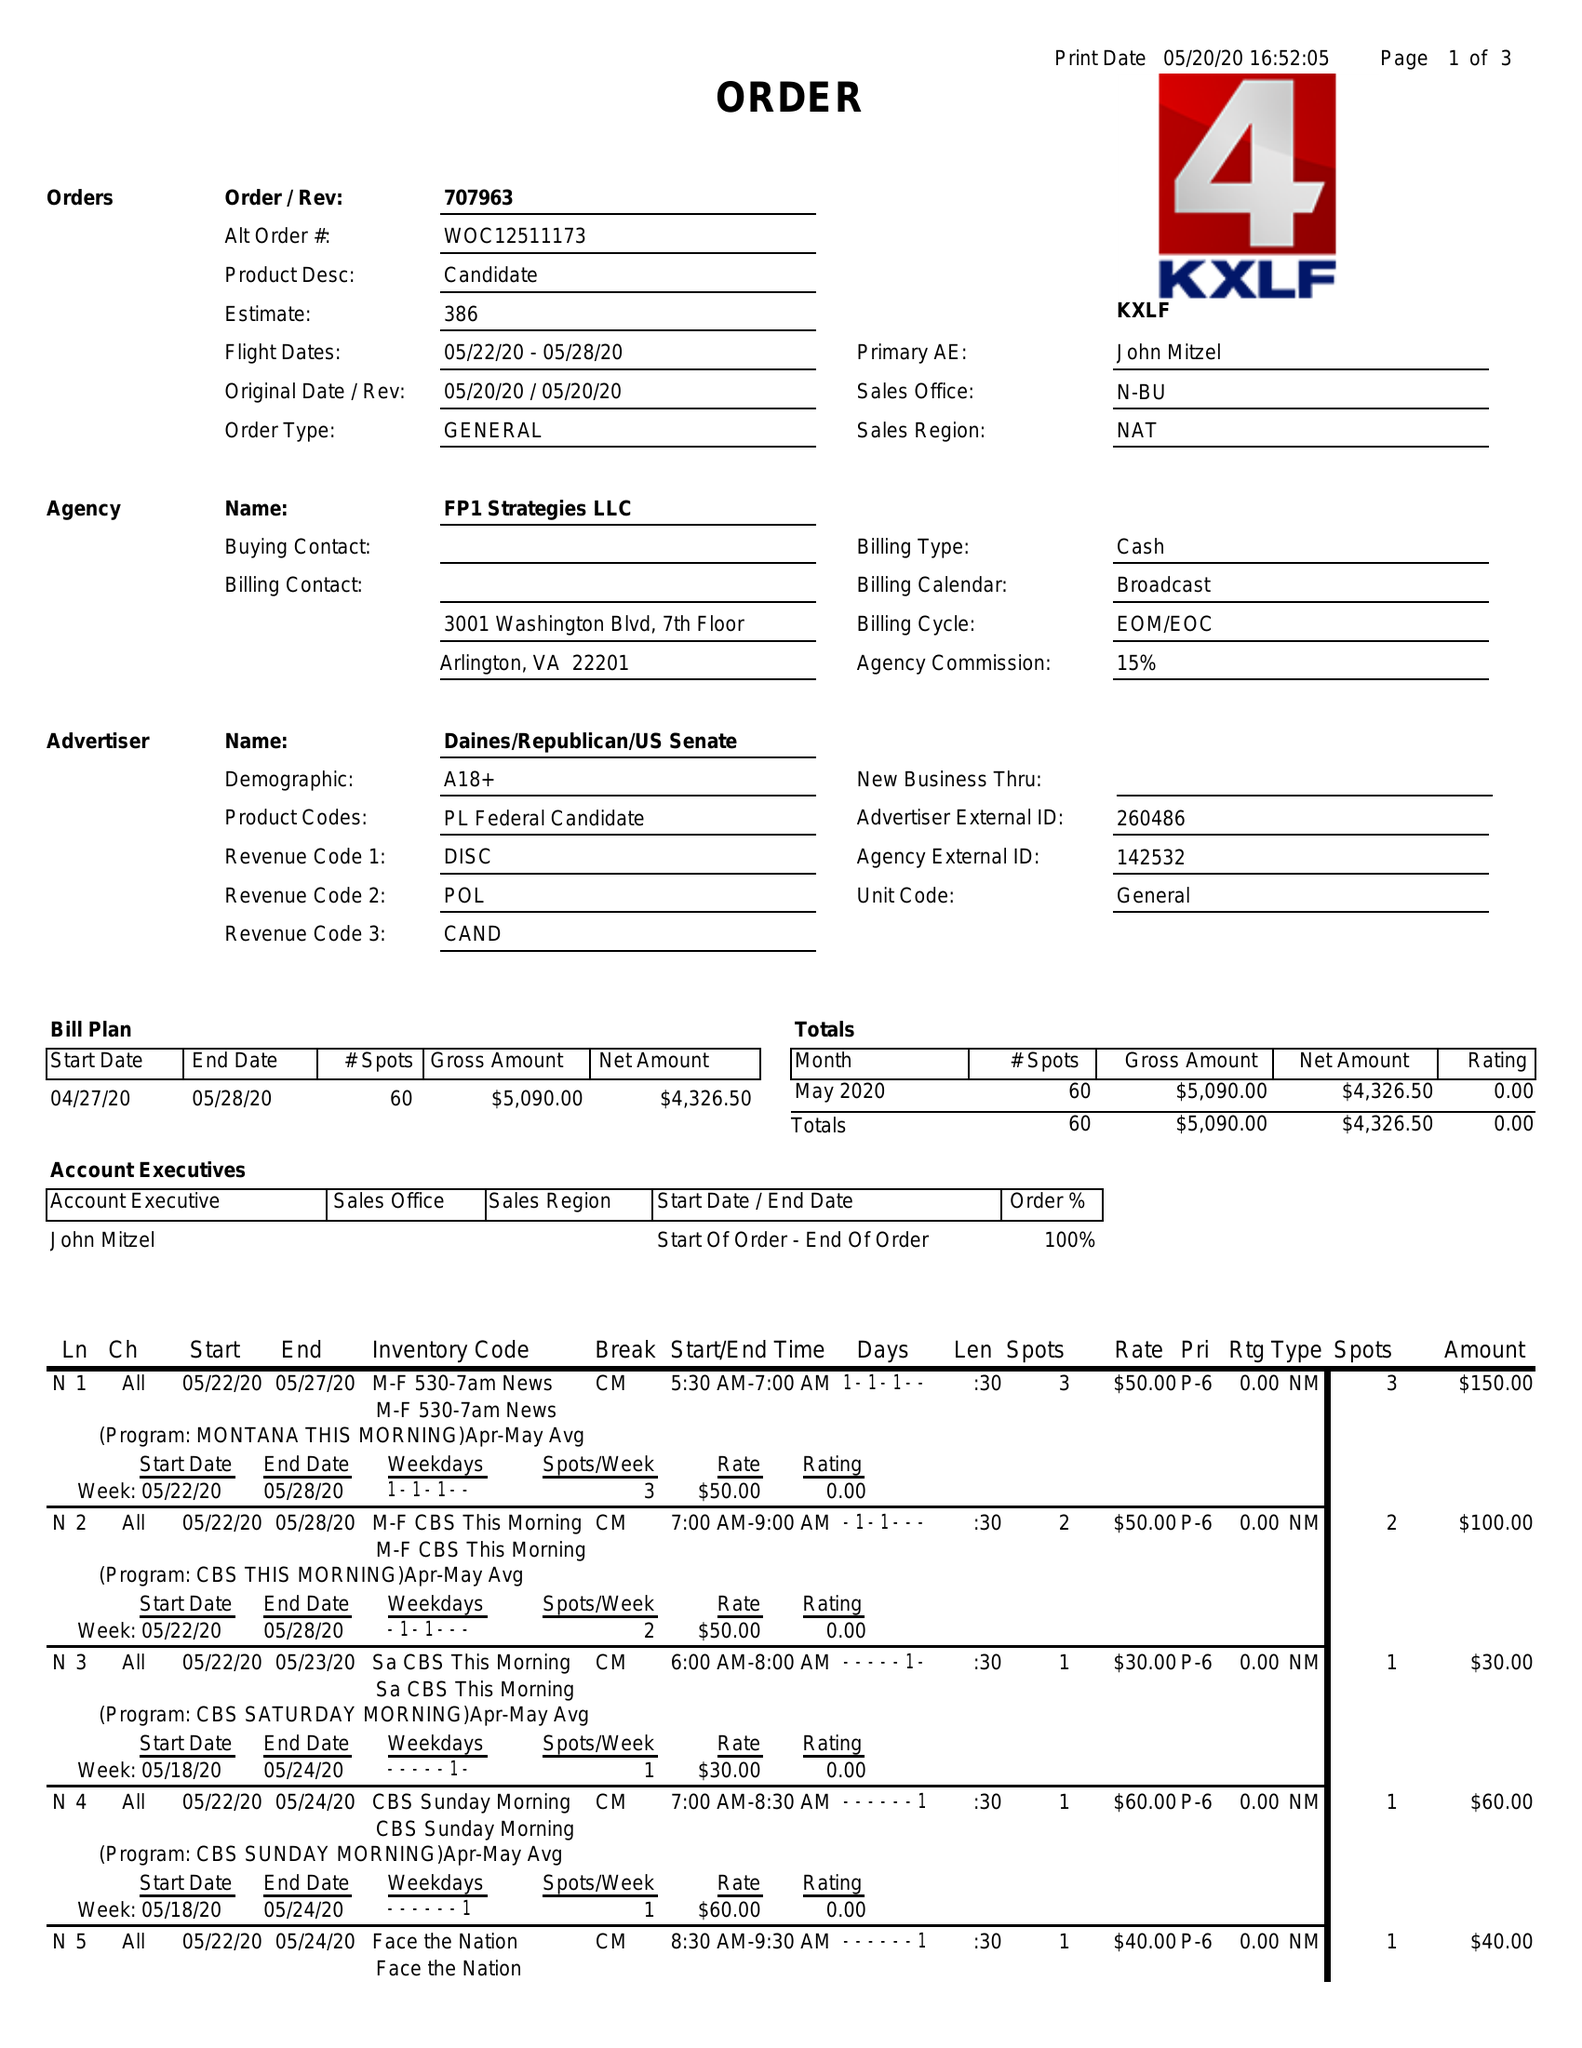What is the value for the contract_num?
Answer the question using a single word or phrase. 707963 